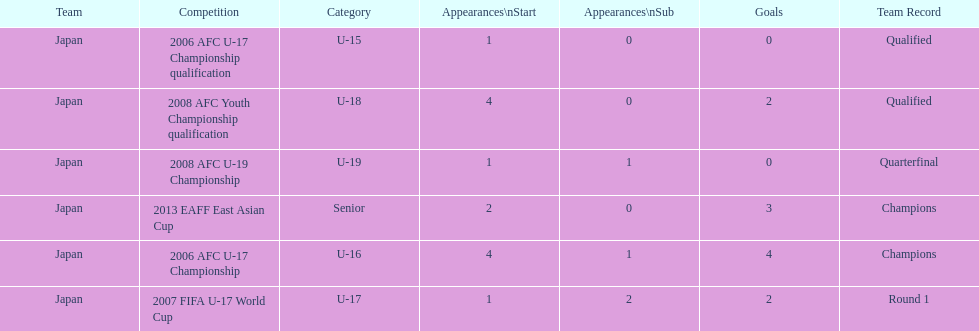Where did japan only score four goals? 2006 AFC U-17 Championship. 